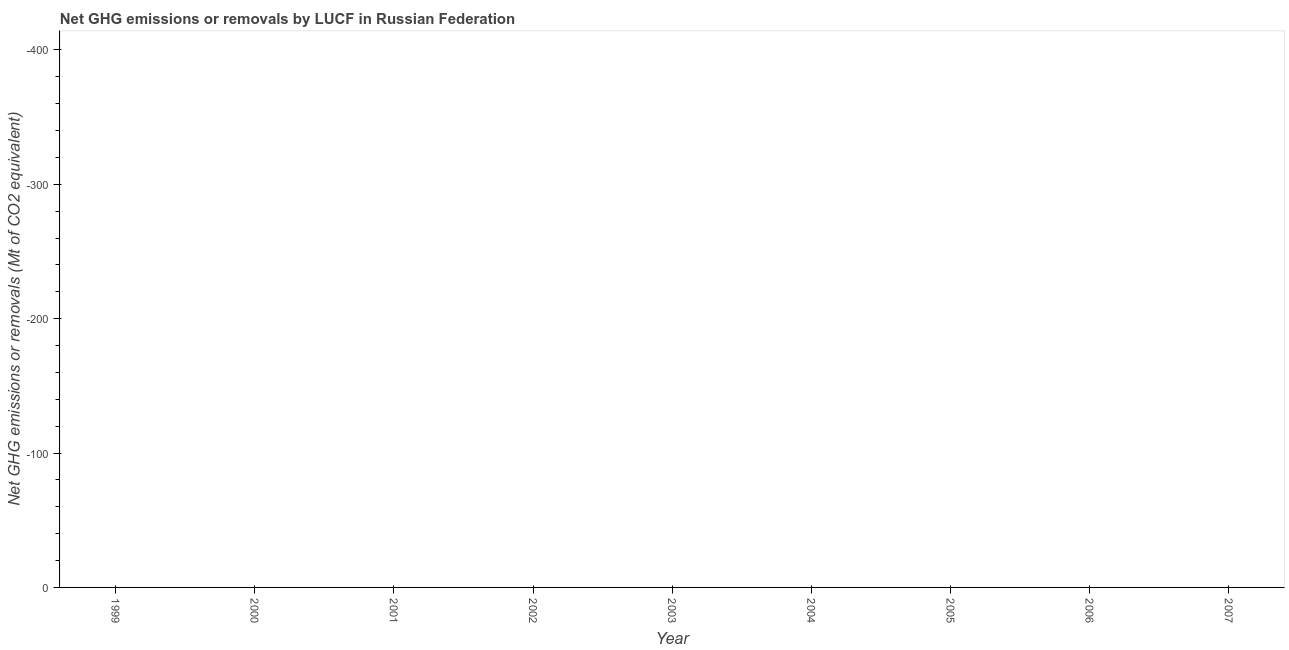What is the ghg net emissions or removals in 2004?
Your response must be concise. 0. What is the sum of the ghg net emissions or removals?
Your answer should be very brief. 0. In how many years, is the ghg net emissions or removals greater than -240 Mt?
Make the answer very short. 0. In how many years, is the ghg net emissions or removals greater than the average ghg net emissions or removals taken over all years?
Give a very brief answer. 0. How many years are there in the graph?
Keep it short and to the point. 9. What is the difference between two consecutive major ticks on the Y-axis?
Give a very brief answer. 100. Does the graph contain any zero values?
Ensure brevity in your answer.  Yes. Does the graph contain grids?
Offer a terse response. No. What is the title of the graph?
Give a very brief answer. Net GHG emissions or removals by LUCF in Russian Federation. What is the label or title of the X-axis?
Give a very brief answer. Year. What is the label or title of the Y-axis?
Provide a succinct answer. Net GHG emissions or removals (Mt of CO2 equivalent). What is the Net GHG emissions or removals (Mt of CO2 equivalent) in 2001?
Keep it short and to the point. 0. What is the Net GHG emissions or removals (Mt of CO2 equivalent) of 2005?
Make the answer very short. 0. 